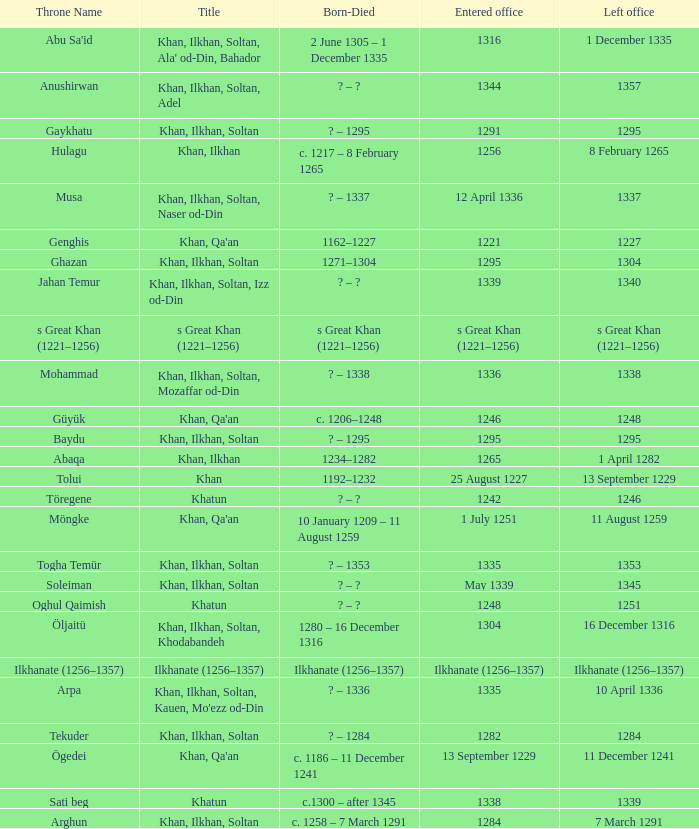What is the born-died that has office of 13 September 1229 as the entered? C. 1186 – 11 december 1241. 